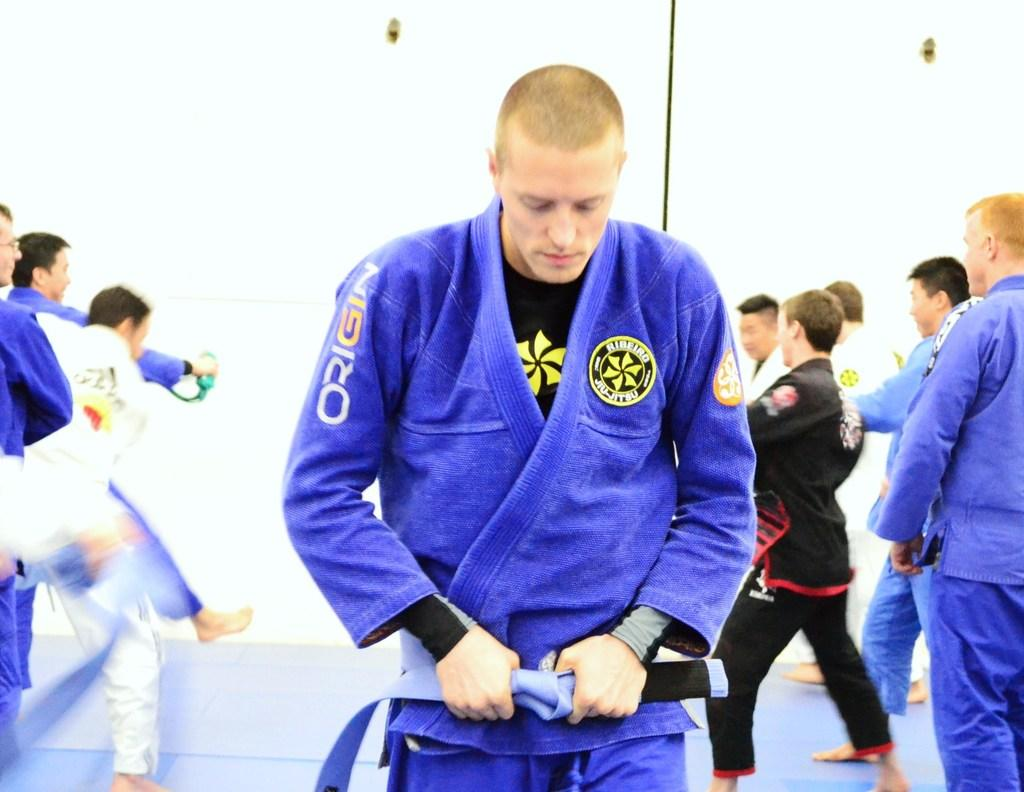<image>
Write a terse but informative summary of the picture. The person wearing the blue jiujitsu outfit in front is sponsored by ORIGIN 